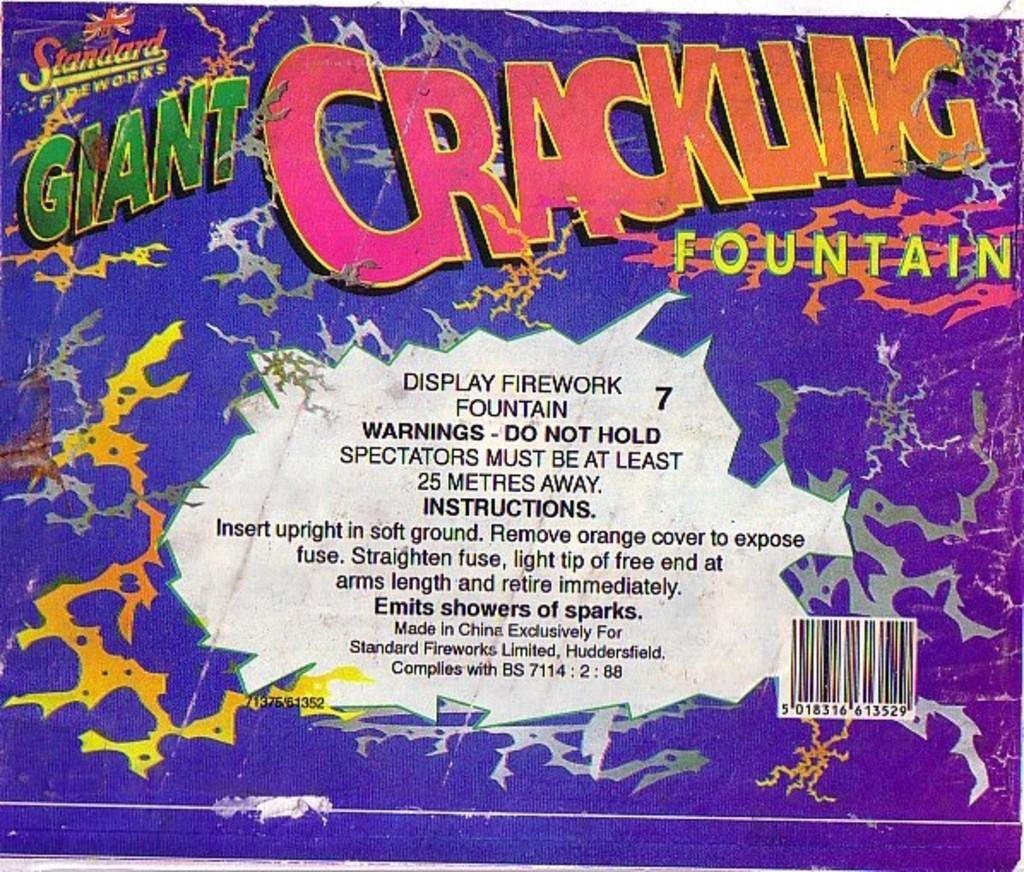What is featured in the picture? There is a poster in the picture. What can be found on the poster? The poster has text on it. Are there any additional elements on the poster? Yes, the poster has a barcode on it. How many geese are attempting to eat the yam in the picture? There are no geese or yams present in the picture; it only features a poster with text and a barcode. 